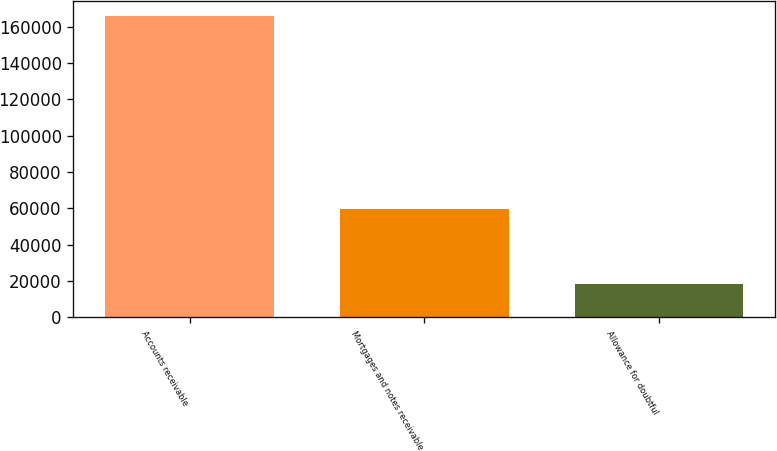Convert chart to OTSL. <chart><loc_0><loc_0><loc_500><loc_500><bar_chart><fcel>Accounts receivable<fcel>Mortgages and notes receivable<fcel>Allowance for doubtful<nl><fcel>166017<fcel>59877<fcel>18203<nl></chart> 